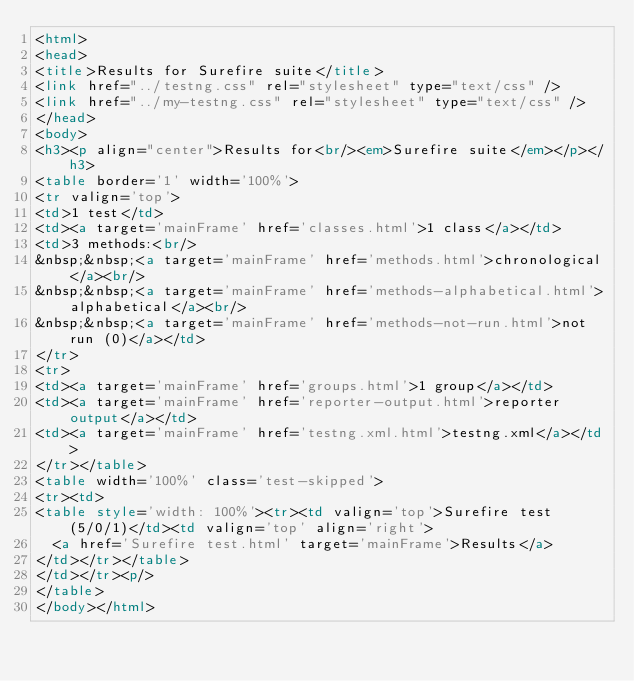<code> <loc_0><loc_0><loc_500><loc_500><_HTML_><html>
<head>
<title>Results for Surefire suite</title>
<link href="../testng.css" rel="stylesheet" type="text/css" />
<link href="../my-testng.css" rel="stylesheet" type="text/css" />
</head>
<body>
<h3><p align="center">Results for<br/><em>Surefire suite</em></p></h3>
<table border='1' width='100%'>
<tr valign='top'>
<td>1 test</td>
<td><a target='mainFrame' href='classes.html'>1 class</a></td>
<td>3 methods:<br/>
&nbsp;&nbsp;<a target='mainFrame' href='methods.html'>chronological</a><br/>
&nbsp;&nbsp;<a target='mainFrame' href='methods-alphabetical.html'>alphabetical</a><br/>
&nbsp;&nbsp;<a target='mainFrame' href='methods-not-run.html'>not run (0)</a></td>
</tr>
<tr>
<td><a target='mainFrame' href='groups.html'>1 group</a></td>
<td><a target='mainFrame' href='reporter-output.html'>reporter output</a></td>
<td><a target='mainFrame' href='testng.xml.html'>testng.xml</a></td>
</tr></table>
<table width='100%' class='test-skipped'>
<tr><td>
<table style='width: 100%'><tr><td valign='top'>Surefire test (5/0/1)</td><td valign='top' align='right'>
  <a href='Surefire test.html' target='mainFrame'>Results</a>
</td></tr></table>
</td></tr><p/>
</table>
</body></html></code> 